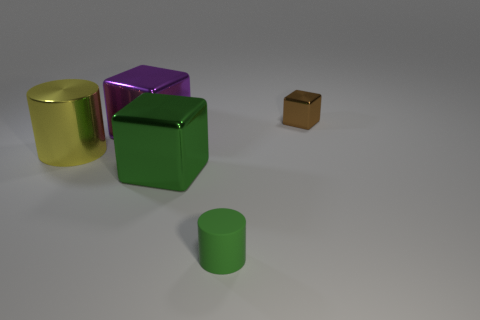What number of objects are both on the left side of the small green thing and behind the yellow thing?
Offer a terse response. 1. How many brown blocks are made of the same material as the green cube?
Offer a terse response. 1. What is the color of the other tiny cube that is made of the same material as the purple block?
Offer a very short reply. Brown. Is the number of big cyan matte things less than the number of yellow metallic cylinders?
Offer a very short reply. Yes. What material is the cylinder to the left of the metal block on the left side of the green object that is left of the rubber thing made of?
Offer a terse response. Metal. What is the material of the big purple object?
Keep it short and to the point. Metal. Does the large metal thing that is in front of the yellow metal thing have the same color as the cylinder that is in front of the yellow shiny cylinder?
Offer a very short reply. Yes. Is the number of yellow cylinders greater than the number of large red rubber cubes?
Make the answer very short. Yes. How many tiny metallic cubes have the same color as the large cylinder?
Offer a very short reply. 0. The small object that is the same shape as the large yellow metallic thing is what color?
Make the answer very short. Green. 